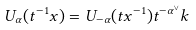<formula> <loc_0><loc_0><loc_500><loc_500>U _ { \alpha } ( t ^ { - 1 } x ) = U _ { - \alpha } ( t x ^ { - 1 } ) t ^ { - \alpha ^ { \vee } } k</formula> 